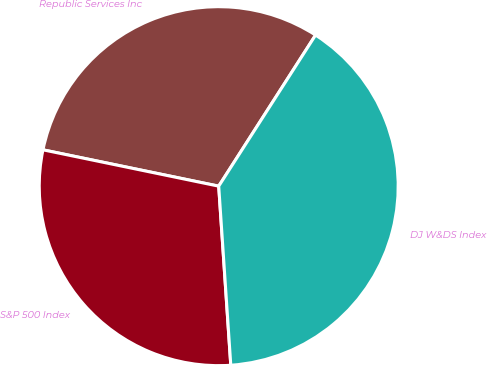Convert chart to OTSL. <chart><loc_0><loc_0><loc_500><loc_500><pie_chart><fcel>Republic Services Inc<fcel>S&P 500 Index<fcel>DJ W&DS Index<nl><fcel>30.83%<fcel>29.32%<fcel>39.86%<nl></chart> 